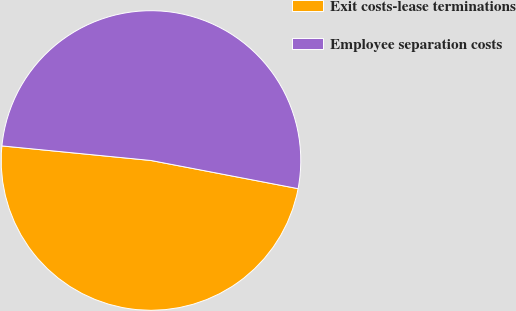Convert chart. <chart><loc_0><loc_0><loc_500><loc_500><pie_chart><fcel>Exit costs-lease terminations<fcel>Employee separation costs<nl><fcel>48.54%<fcel>51.46%<nl></chart> 